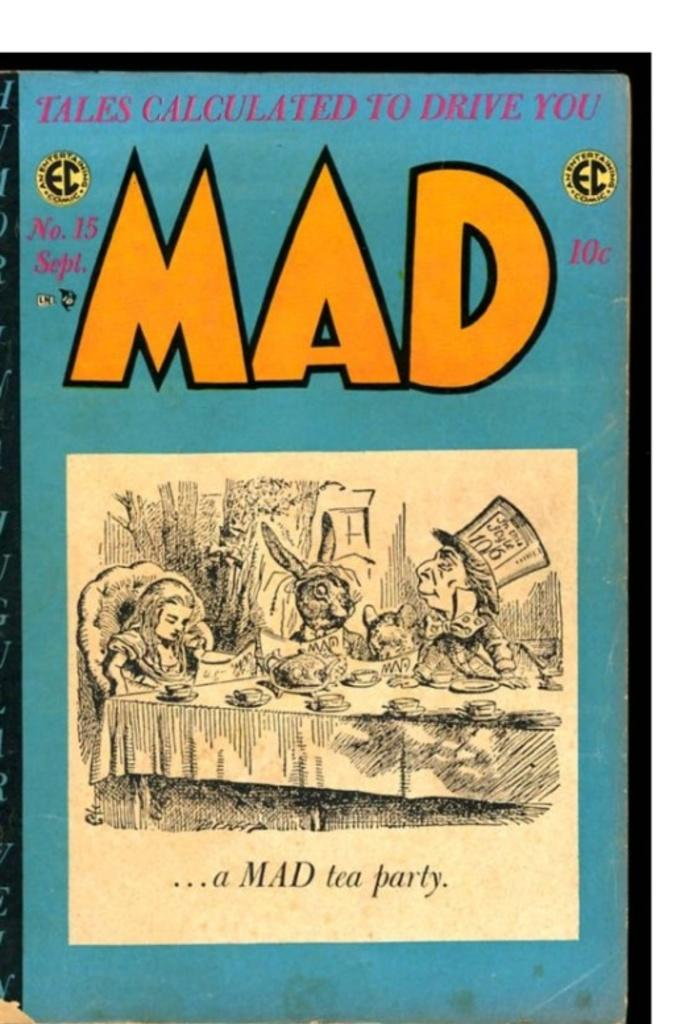What are the people in the image doing? The people in the image are sitting. What can be seen on the table in the image? There are food items on the table. What is written on the image? There is something written on the image. What color is the background of the image? The background of the image is blue. What type of story can be heard in the background of the image? There is no story or audio present in the image, so it cannot be heard. 